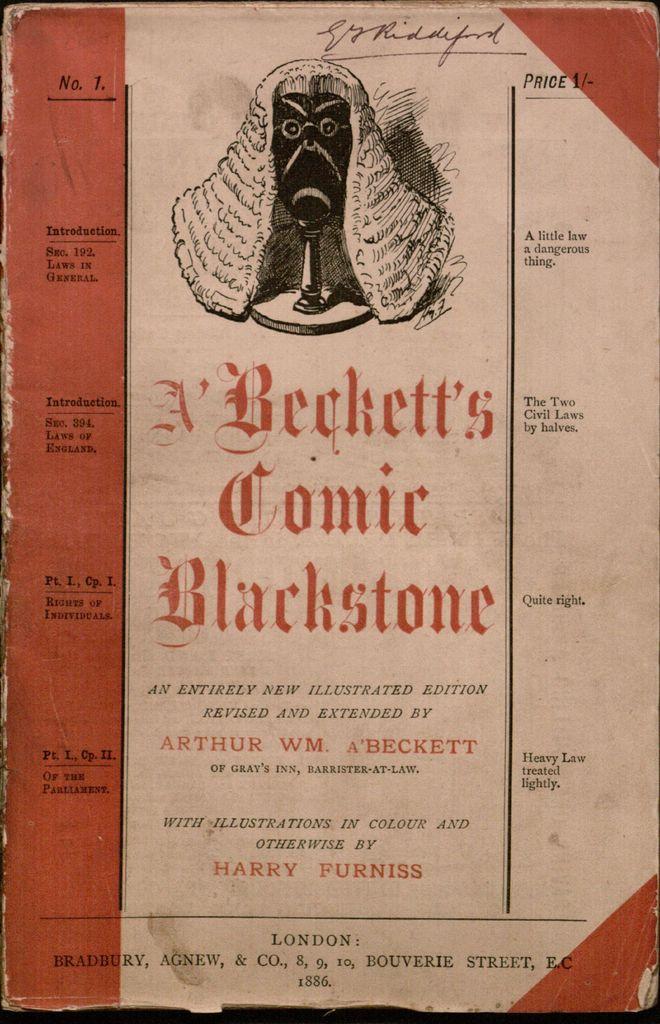What is the word containing "stone" in the title?
Provide a short and direct response. Blackstone. Was harry furniss a prolific illustrator?
Offer a very short reply. Unanswerable. 